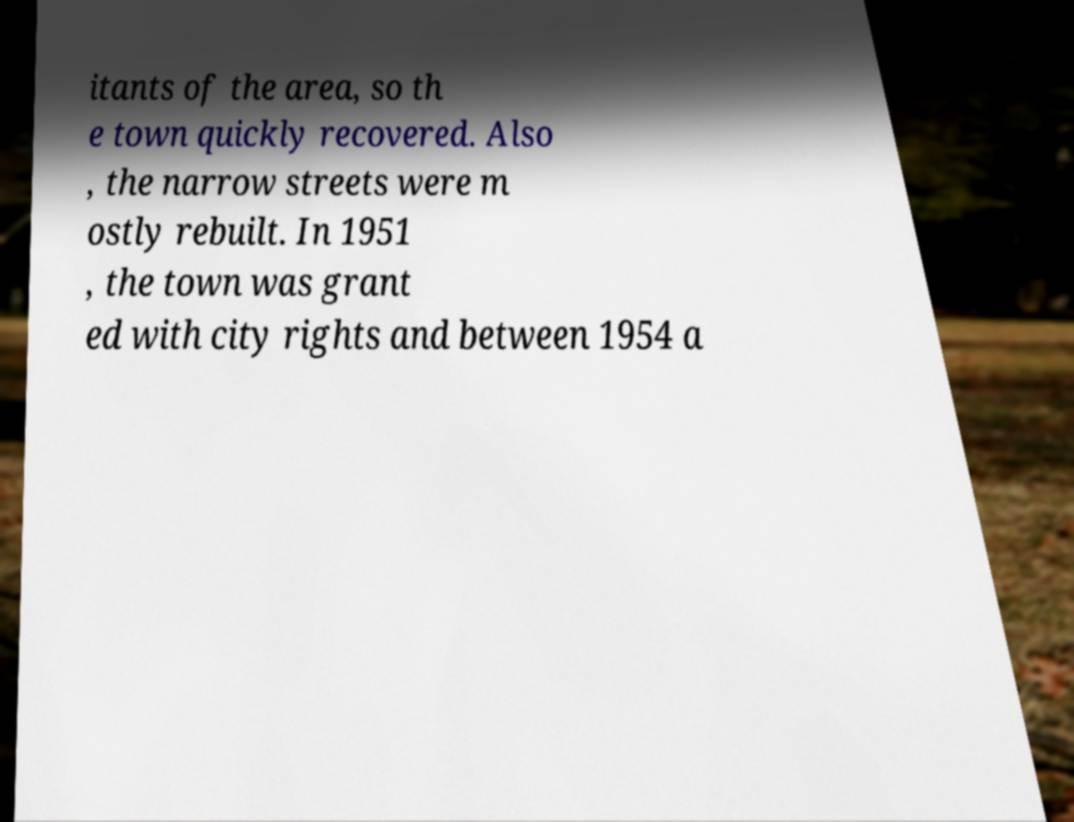Please identify and transcribe the text found in this image. itants of the area, so th e town quickly recovered. Also , the narrow streets were m ostly rebuilt. In 1951 , the town was grant ed with city rights and between 1954 a 